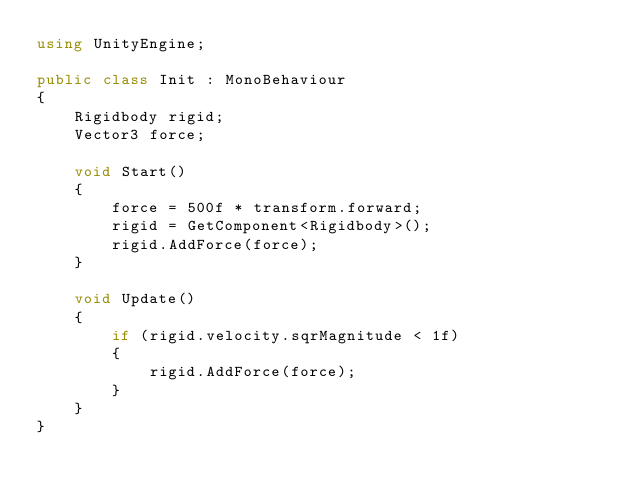Convert code to text. <code><loc_0><loc_0><loc_500><loc_500><_C#_>using UnityEngine;

public class Init : MonoBehaviour
{
    Rigidbody rigid;
    Vector3 force;

    void Start()
    {
        force = 500f * transform.forward;
        rigid = GetComponent<Rigidbody>();
        rigid.AddForce(force);
    }

    void Update()
    {
        if (rigid.velocity.sqrMagnitude < 1f)
        {
            rigid.AddForce(force);
        }
    }
}
</code> 